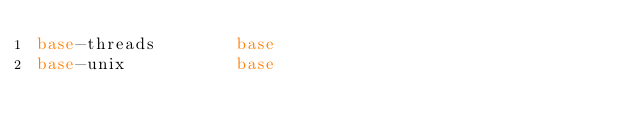Convert code to text. <code><loc_0><loc_0><loc_500><loc_500><_HTML_>base-threads        base
base-unix           base</code> 